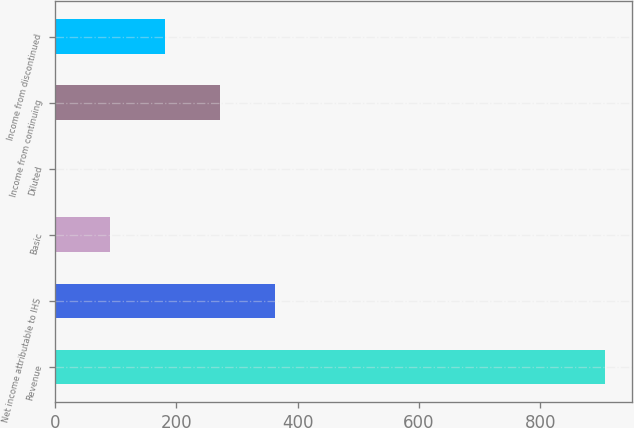Convert chart to OTSL. <chart><loc_0><loc_0><loc_500><loc_500><bar_chart><fcel>Revenue<fcel>Net income attributable to IHS<fcel>Basic<fcel>Diluted<fcel>Income from continuing<fcel>Income from discontinued<nl><fcel>906.1<fcel>362.6<fcel>90.83<fcel>0.24<fcel>272.01<fcel>181.42<nl></chart> 